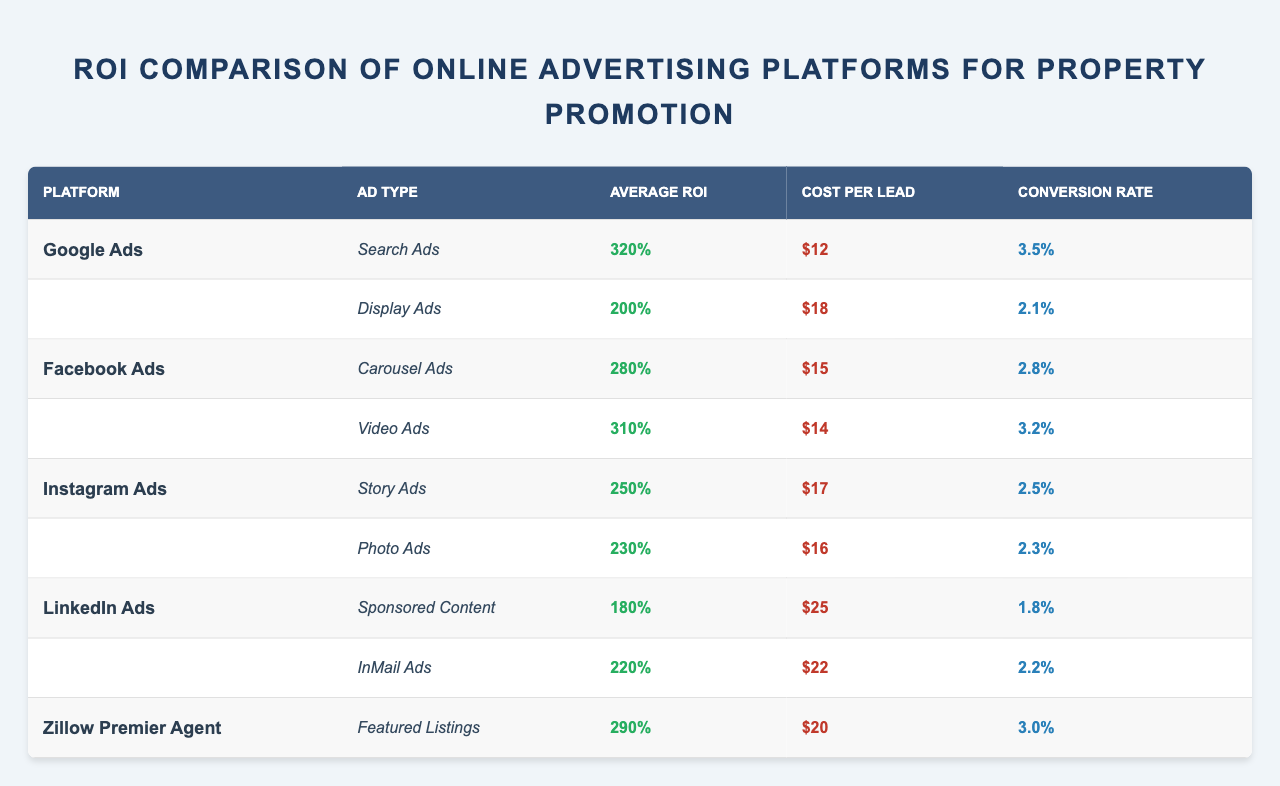What is the average ROI for Google Ads' Search Ads? The table shows that the average ROI for Google Ads' Search Ads is listed directly. Therefore, the value can be retrieved as 320%.
Answer: 320% Which ad type on Facebook Ads has a higher conversion rate, Carousel Ads or Video Ads? The table provides the conversion rates for both Carousel Ads (2.8%) and Video Ads (3.2%). Comparing these values shows that Video Ads have a higher conversion rate.
Answer: Video Ads What is the average cost per lead across all platforms? To find the average cost per lead, sum up all the costs per lead: $12 (Google Search) + $18 (Google Display) + $15 (Facebook Carousel) + $14 (Facebook Video) + $17 (Instagram Story) + $16 (Instagram Photo) + $25 (LinkedIn Sponsored) + $22 (LinkedIn InMail) + $20 (Zillow) = $ 12 + 18 + 15 + 14 + 17 +16 + 25 +22 + 20 = 149. Then divide by the number of ad types (9): 149/9 = $16.56.
Answer: $16.56 Which platform has the highest average ROI? By reviewing the average ROIs listed in the table, Google Ads' Search Ads have the highest ROI at 320%.
Answer: Google Ads What is the difference in average ROI between Instagram Ads' Story Ads and LinkedIn Ads' Sponsored Content? The average ROI for Instagram's Story Ads is 250%, and for LinkedIn's Sponsored Content, it is 180%. The difference between them is 250% - 180% = 70%.
Answer: 70% Does Zillow Premier Agent have more than one ad type listed? The table shows that Zillow Premier Agent has only one ad type listed, which is Featured Listings. Therefore, the answer is no.
Answer: No What is the total average ROI for Facebook Ads? The total average ROI for Facebook Ads can be calculated by summing the average ROIs for both Carousel Ads (280%) and Video Ads (310%): 280% + 310% = 590%. Then, divide by the number of ad types (2): 590% / 2 = 295%.
Answer: 295% Which platform has the lowest cost per lead? A comparison of the cost per lead from the table indicates that Google Ads' Search Ads has the lowest cost per lead at $12.
Answer: Google Ads Is the conversion rate for Instagram's Photo Ads higher than that for LinkedIn's InMail Ads? The conversion rate for Instagram's Photo Ads is 2.3%, while LinkedIn's InMail Ads have a conversion rate of 2.2%. Since 2.3% is higher, the answer is yes.
Answer: Yes What is the average ROI for all the ad types across all platforms? First, sum all average ROIs: 320% (Google Search) + 200% (Google Display) + 280% (Facebook Carousel) + 310% (Facebook Video) + 250% (Instagram Story) + 230% (Instagram Photo) + 180% (LinkedIn Sponsored) + 220% (LinkedIn InMail) + 290% (Zillow) = 2280%. Then, divide by the number of ad types (9): 2280% / 9 = 253.33%.
Answer: 253.33% 